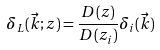<formula> <loc_0><loc_0><loc_500><loc_500>\delta _ { L } ( \vec { k } ; z ) = \frac { D ( z ) } { D ( z _ { i } ) } \delta _ { i } ( \vec { k } ) \,</formula> 